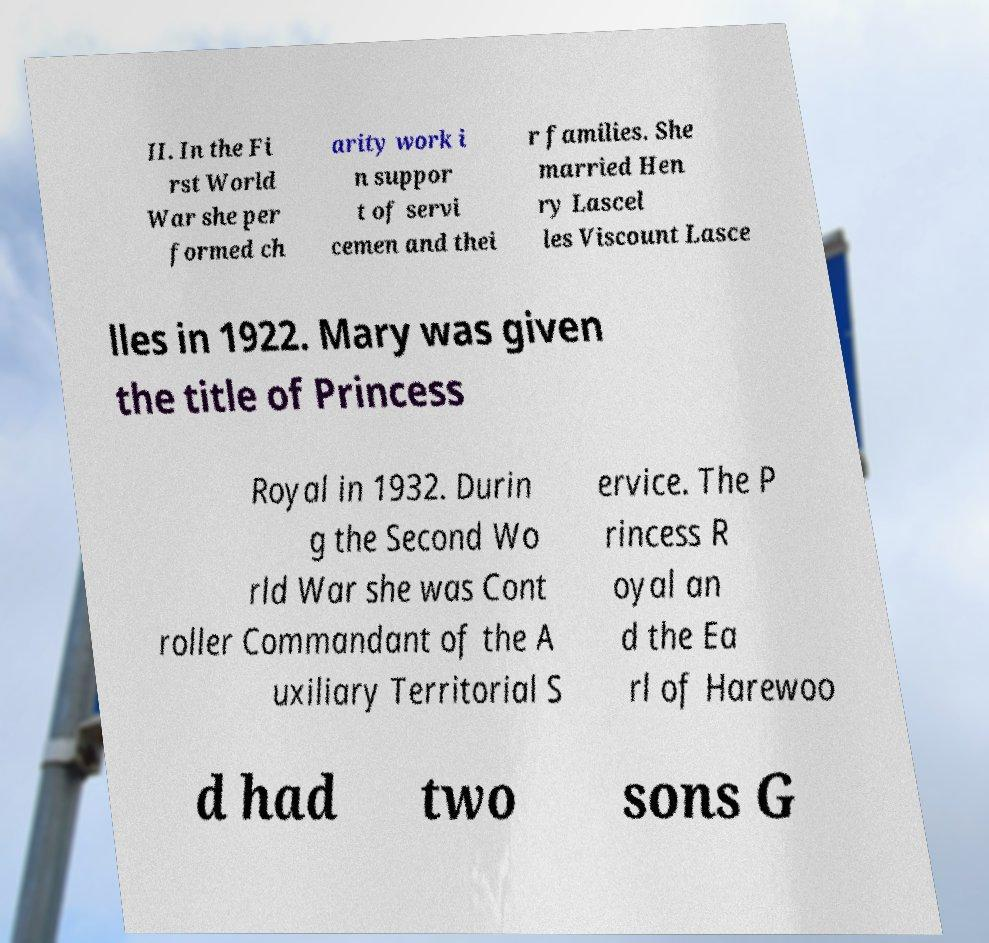Please identify and transcribe the text found in this image. II. In the Fi rst World War she per formed ch arity work i n suppor t of servi cemen and thei r families. She married Hen ry Lascel les Viscount Lasce lles in 1922. Mary was given the title of Princess Royal in 1932. Durin g the Second Wo rld War she was Cont roller Commandant of the A uxiliary Territorial S ervice. The P rincess R oyal an d the Ea rl of Harewoo d had two sons G 